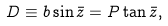Convert formula to latex. <formula><loc_0><loc_0><loc_500><loc_500>D \equiv b \sin \bar { z } = P \tan \bar { z } ,</formula> 